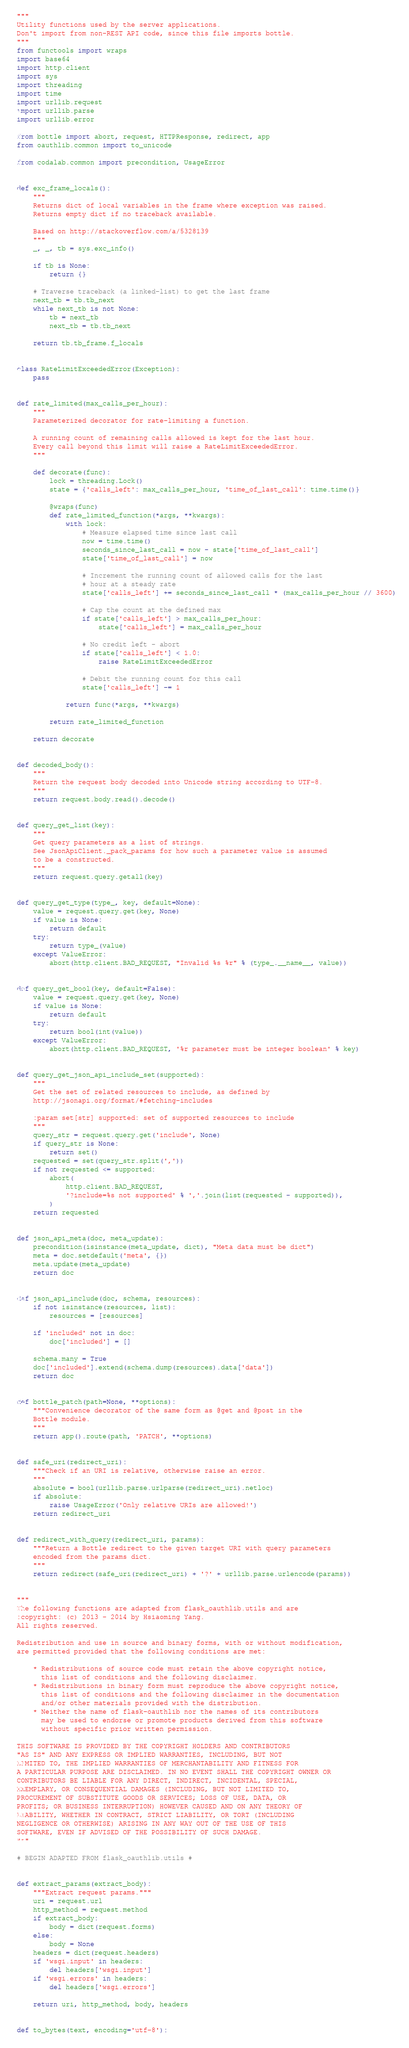<code> <loc_0><loc_0><loc_500><loc_500><_Python_>"""
Utility functions used by the server applications.
Don't import from non-REST API code, since this file imports bottle.
"""
from functools import wraps
import base64
import http.client
import sys
import threading
import time
import urllib.request
import urllib.parse
import urllib.error

from bottle import abort, request, HTTPResponse, redirect, app
from oauthlib.common import to_unicode

from codalab.common import precondition, UsageError


def exc_frame_locals():
    """
    Returns dict of local variables in the frame where exception was raised.
    Returns empty dict if no traceback available.

    Based on http://stackoverflow.com/a/5328139
    """
    _, _, tb = sys.exc_info()

    if tb is None:
        return {}

    # Traverse traceback (a linked-list) to get the last frame
    next_tb = tb.tb_next
    while next_tb is not None:
        tb = next_tb
        next_tb = tb.tb_next

    return tb.tb_frame.f_locals


class RateLimitExceededError(Exception):
    pass


def rate_limited(max_calls_per_hour):
    """
    Parameterized decorator for rate-limiting a function.

    A running count of remaining calls allowed is kept for the last hour.
    Every call beyond this limit will raise a RateLimitExceededError.
    """

    def decorate(func):
        lock = threading.Lock()
        state = {'calls_left': max_calls_per_hour, 'time_of_last_call': time.time()}

        @wraps(func)
        def rate_limited_function(*args, **kwargs):
            with lock:
                # Measure elapsed time since last call
                now = time.time()
                seconds_since_last_call = now - state['time_of_last_call']
                state['time_of_last_call'] = now

                # Increment the running count of allowed calls for the last
                # hour at a steady rate
                state['calls_left'] += seconds_since_last_call * (max_calls_per_hour // 3600)

                # Cap the count at the defined max
                if state['calls_left'] > max_calls_per_hour:
                    state['calls_left'] = max_calls_per_hour

                # No credit left - abort
                if state['calls_left'] < 1.0:
                    raise RateLimitExceededError

                # Debit the running count for this call
                state['calls_left'] -= 1

            return func(*args, **kwargs)

        return rate_limited_function

    return decorate


def decoded_body():
    """
    Return the request body decoded into Unicode string according to UTF-8.
    """
    return request.body.read().decode()


def query_get_list(key):
    """
    Get query parameters as a list of strings.
    See JsonApiClient._pack_params for how such a parameter value is assumed
    to be a constructed.
    """
    return request.query.getall(key)


def query_get_type(type_, key, default=None):
    value = request.query.get(key, None)
    if value is None:
        return default
    try:
        return type_(value)
    except ValueError:
        abort(http.client.BAD_REQUEST, "Invalid %s %r" % (type_.__name__, value))


def query_get_bool(key, default=False):
    value = request.query.get(key, None)
    if value is None:
        return default
    try:
        return bool(int(value))
    except ValueError:
        abort(http.client.BAD_REQUEST, '%r parameter must be integer boolean' % key)


def query_get_json_api_include_set(supported):
    """
    Get the set of related resources to include, as defined by
    http://jsonapi.org/format/#fetching-includes

    :param set[str] supported: set of supported resources to include
    """
    query_str = request.query.get('include', None)
    if query_str is None:
        return set()
    requested = set(query_str.split(','))
    if not requested <= supported:
        abort(
            http.client.BAD_REQUEST,
            '?include=%s not supported' % ','.join(list(requested - supported)),
        )
    return requested


def json_api_meta(doc, meta_update):
    precondition(isinstance(meta_update, dict), "Meta data must be dict")
    meta = doc.setdefault('meta', {})
    meta.update(meta_update)
    return doc


def json_api_include(doc, schema, resources):
    if not isinstance(resources, list):
        resources = [resources]

    if 'included' not in doc:
        doc['included'] = []

    schema.many = True
    doc['included'].extend(schema.dump(resources).data['data'])
    return doc


def bottle_patch(path=None, **options):
    """Convenience decorator of the same form as @get and @post in the
    Bottle module.
    """
    return app().route(path, 'PATCH', **options)


def safe_uri(redirect_uri):
    """Check if an URI is relative, otherwise raise an error.
    """
    absolute = bool(urllib.parse.urlparse(redirect_uri).netloc)
    if absolute:
        raise UsageError('Only relative URIs are allowed!')
    return redirect_uri


def redirect_with_query(redirect_uri, params):
    """Return a Bottle redirect to the given target URI with query parameters
    encoded from the params dict.
    """
    return redirect(safe_uri(redirect_uri) + '?' + urllib.parse.urlencode(params))


"""
The following functions are adapted from flask_oauthlib.utils and are
:copyright: (c) 2013 - 2014 by Hsiaoming Yang.
All rights reserved.

Redistribution and use in source and binary forms, with or without modification,
are permitted provided that the following conditions are met:

    * Redistributions of source code must retain the above copyright notice,
      this list of conditions and the following disclaimer.
    * Redistributions in binary form must reproduce the above copyright notice,
      this list of conditions and the following disclaimer in the documentation
      and/or other materials provided with the distribution.
    * Neither the name of flask-oauthlib nor the names of its contributors
      may be used to endorse or promote products derived from this software
      without specific prior written permission.

THIS SOFTWARE IS PROVIDED BY THE COPYRIGHT HOLDERS AND CONTRIBUTORS
"AS IS" AND ANY EXPRESS OR IMPLIED WARRANTIES, INCLUDING, BUT NOT
LIMITED TO, THE IMPLIED WARRANTIES OF MERCHANTABILITY AND FITNESS FOR
A PARTICULAR PURPOSE ARE DISCLAIMED. IN NO EVENT SHALL THE COPYRIGHT OWNER OR
CONTRIBUTORS BE LIABLE FOR ANY DIRECT, INDIRECT, INCIDENTAL, SPECIAL,
EXEMPLARY, OR CONSEQUENTIAL DAMAGES (INCLUDING, BUT NOT LIMITED TO,
PROCUREMENT OF SUBSTITUTE GOODS OR SERVICES; LOSS OF USE, DATA, OR
PROFITS; OR BUSINESS INTERRUPTION) HOWEVER CAUSED AND ON ANY THEORY OF
LIABILITY, WHETHER IN CONTRACT, STRICT LIABILITY, OR TORT (INCLUDING
NEGLIGENCE OR OTHERWISE) ARISING IN ANY WAY OUT OF THE USE OF THIS
SOFTWARE, EVEN IF ADVISED OF THE POSSIBILITY OF SUCH DAMAGE.
"""

# BEGIN ADAPTED FROM flask_oauthlib.utils #


def extract_params(extract_body):
    """Extract request params."""
    uri = request.url
    http_method = request.method
    if extract_body:
        body = dict(request.forms)
    else:
        body = None
    headers = dict(request.headers)
    if 'wsgi.input' in headers:
        del headers['wsgi.input']
    if 'wsgi.errors' in headers:
        del headers['wsgi.errors']

    return uri, http_method, body, headers


def to_bytes(text, encoding='utf-8'):</code> 